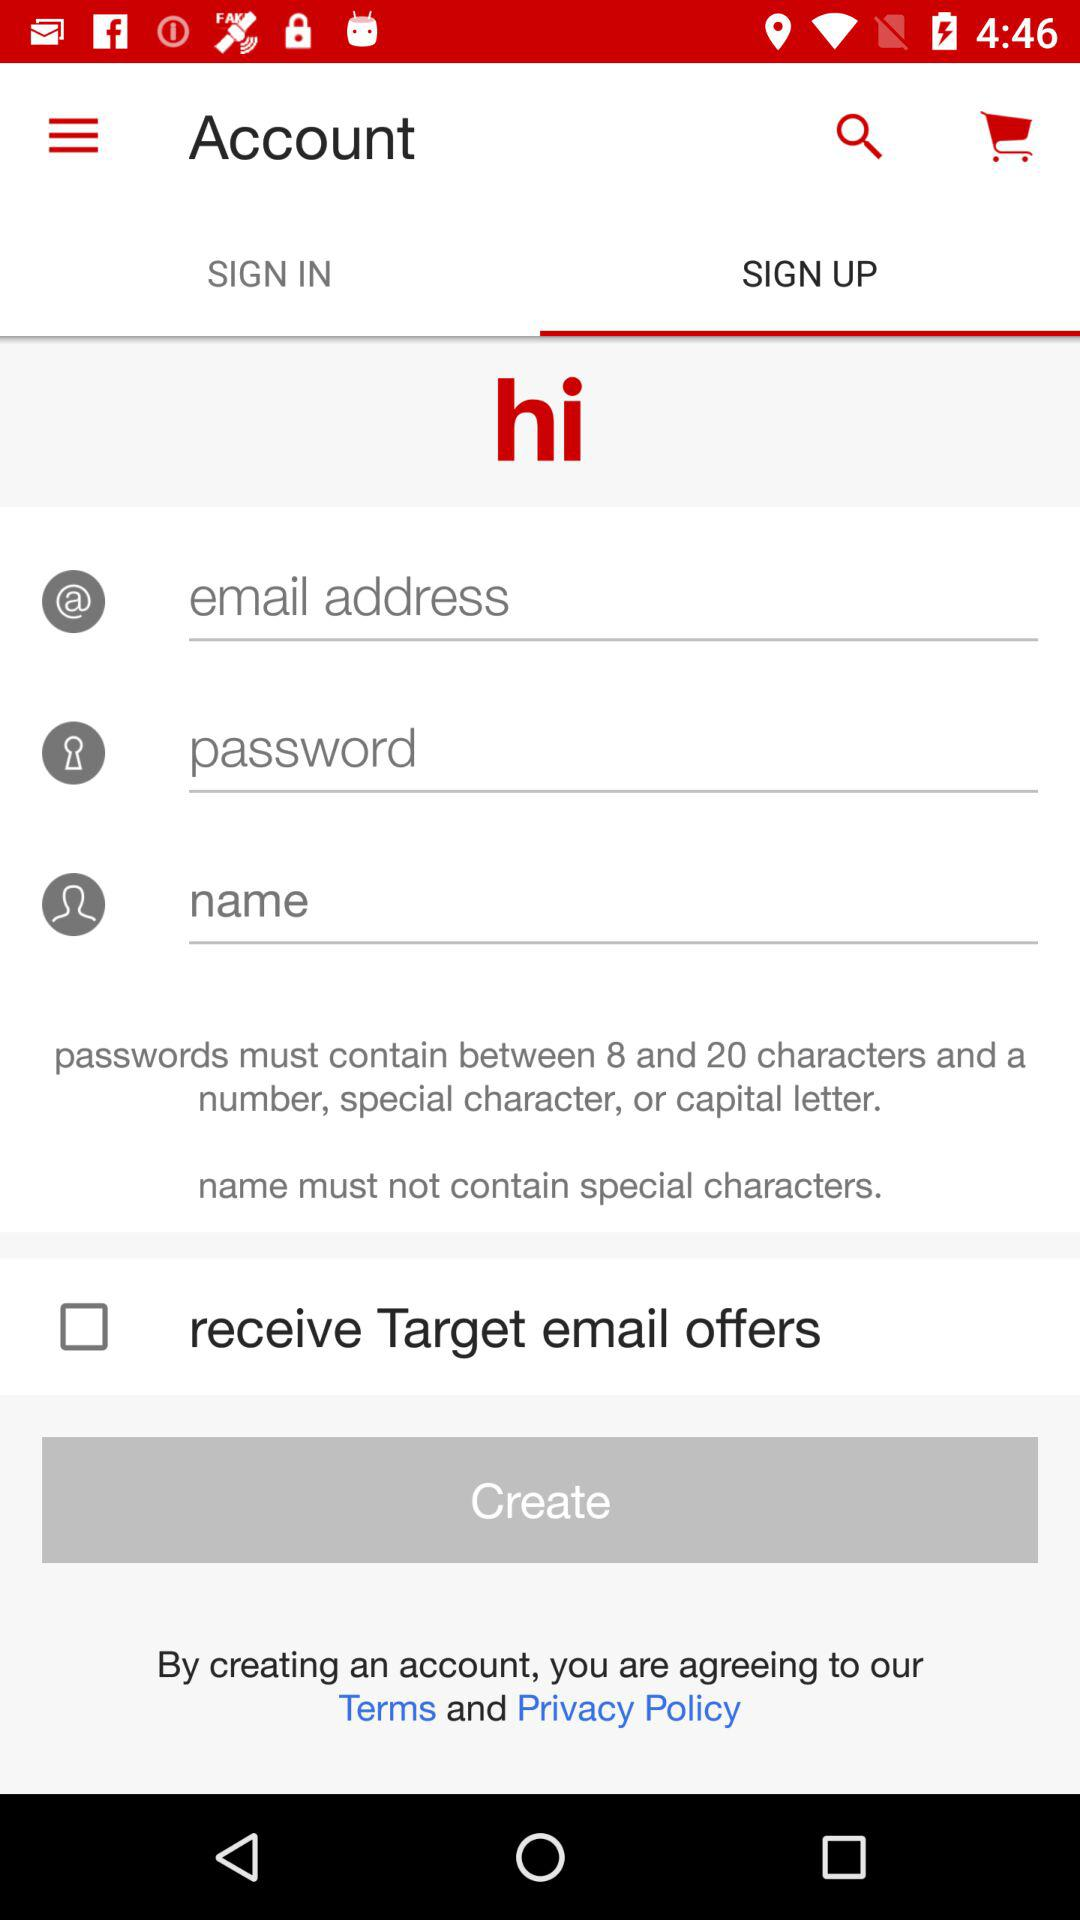Which tab is selected? The selected tab is "SIGN UP". 